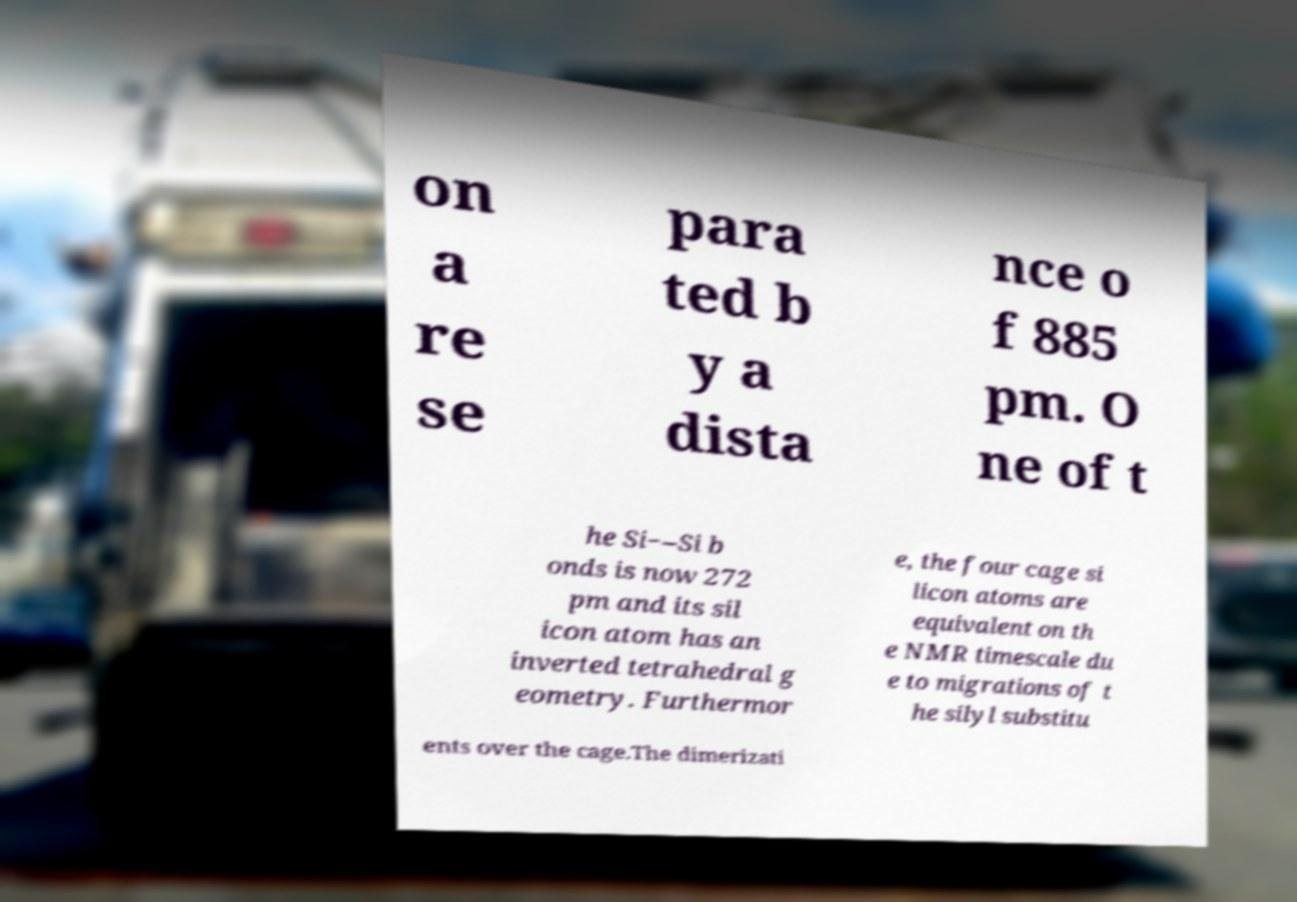There's text embedded in this image that I need extracted. Can you transcribe it verbatim? on a re se para ted b y a dista nce o f 885 pm. O ne of t he Si−–Si b onds is now 272 pm and its sil icon atom has an inverted tetrahedral g eometry. Furthermor e, the four cage si licon atoms are equivalent on th e NMR timescale du e to migrations of t he silyl substitu ents over the cage.The dimerizati 